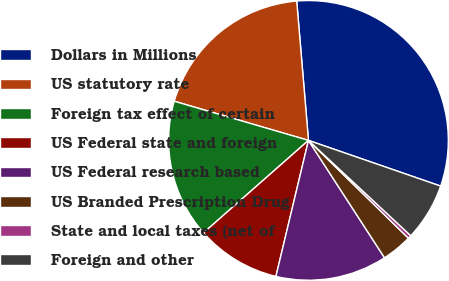Convert chart to OTSL. <chart><loc_0><loc_0><loc_500><loc_500><pie_chart><fcel>Dollars in Millions<fcel>US statutory rate<fcel>Foreign tax effect of certain<fcel>US Federal state and foreign<fcel>US Federal research based<fcel>US Branded Prescription Drug<fcel>State and local taxes (net of<fcel>Foreign and other<nl><fcel>31.64%<fcel>19.14%<fcel>16.01%<fcel>9.77%<fcel>12.89%<fcel>3.52%<fcel>0.39%<fcel>6.64%<nl></chart> 